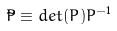Convert formula to latex. <formula><loc_0><loc_0><loc_500><loc_500>\tilde { P } \equiv d e t ( P ) P ^ { - 1 }</formula> 